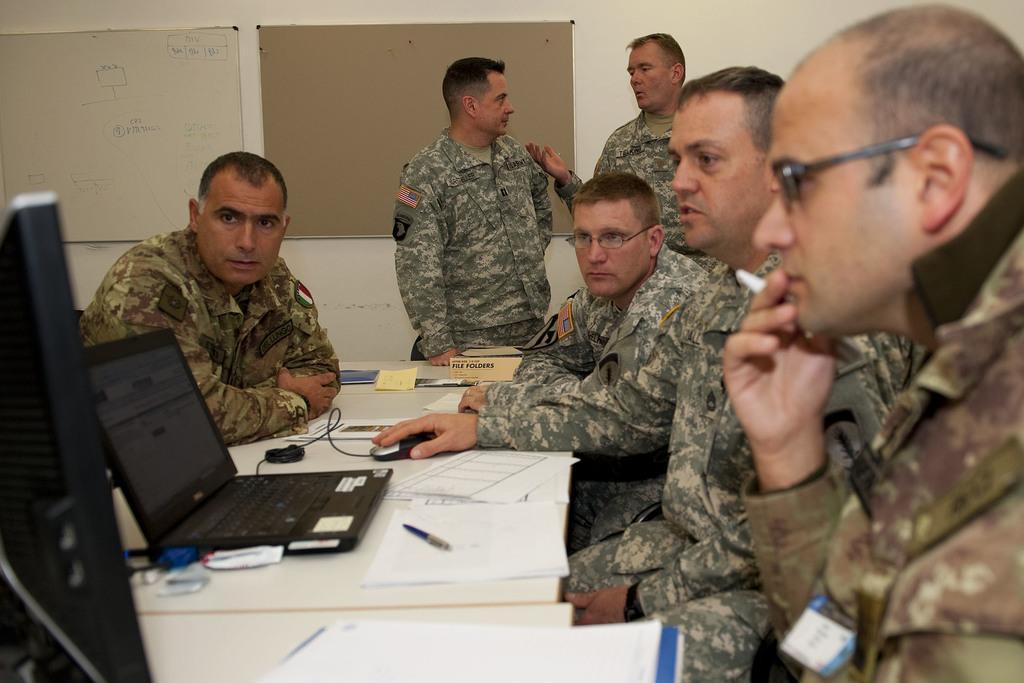Could you give a brief overview of what you see in this image? In this image we can see a few people, among them some are standing and some are sitting on the chairs, in front of them, we can see the tables, on the tables, there are papers, pen, name boards, laptop and some other objects, in the background we can see the boards on the wall. 